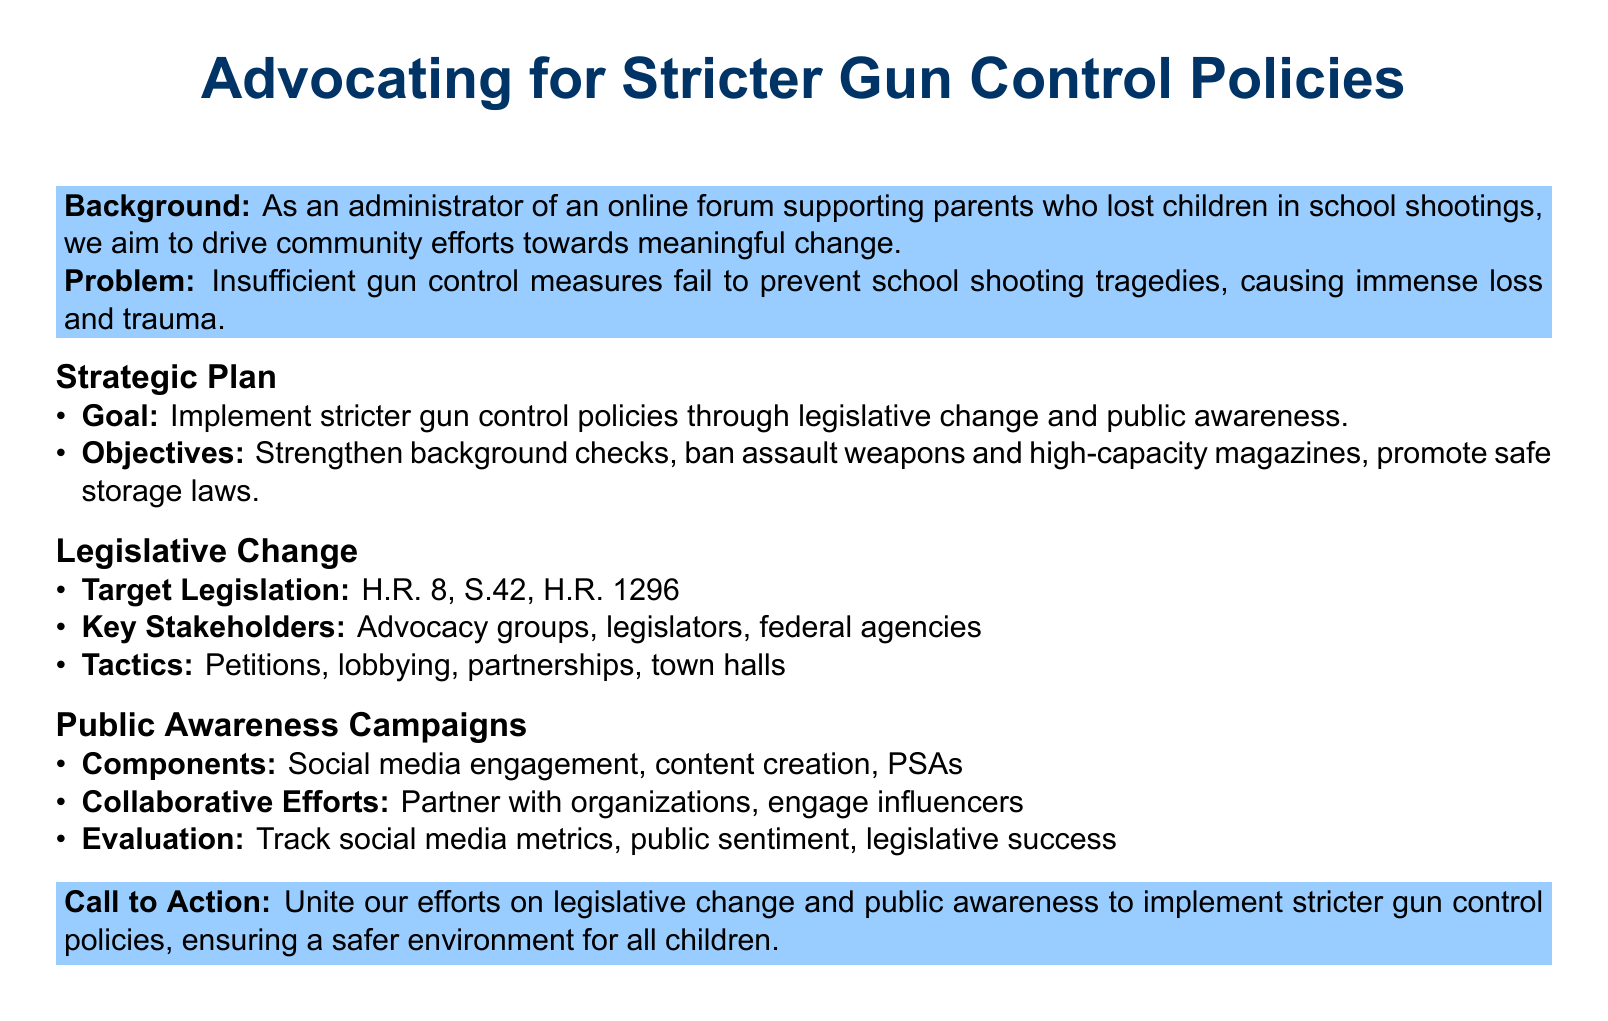What is the main goal of the proposal? The main goal is to implement stricter gun control policies through legislative change and public awareness.
Answer: Implement stricter gun control policies Which bill focuses on background checks? H.R. 8 is a target legislation that aims to strengthen background checks.
Answer: H.R. 8 What is one of the proposed safe storage laws? The proposal includes promoting safe storage laws as an objective.
Answer: Safe storage laws Who are the key stakeholders mentioned in the legislative change section? The key stakeholders include advocacy groups, legislators, and federal agencies.
Answer: Advocacy groups, legislators, federal agencies What type of campaign is emphasized in the proposal? The proposal emphasizes public awareness campaigns as a major strategy.
Answer: Public awareness campaigns Which social media strategy is included in the public awareness campaign? Social media engagement is listed as a component of the campaigns.
Answer: Social media engagement What is one method of evaluation for the campaigns? The proposal suggests tracking social media metrics to evaluate campaign success.
Answer: Track social media metrics What type of document is this? The document is a proposal advocating for stricter gun control policies.
Answer: Proposal What does the call to action encourage? The call to action encourages unity towards legislative change and public awareness.
Answer: Unite efforts on legislative change and public awareness 